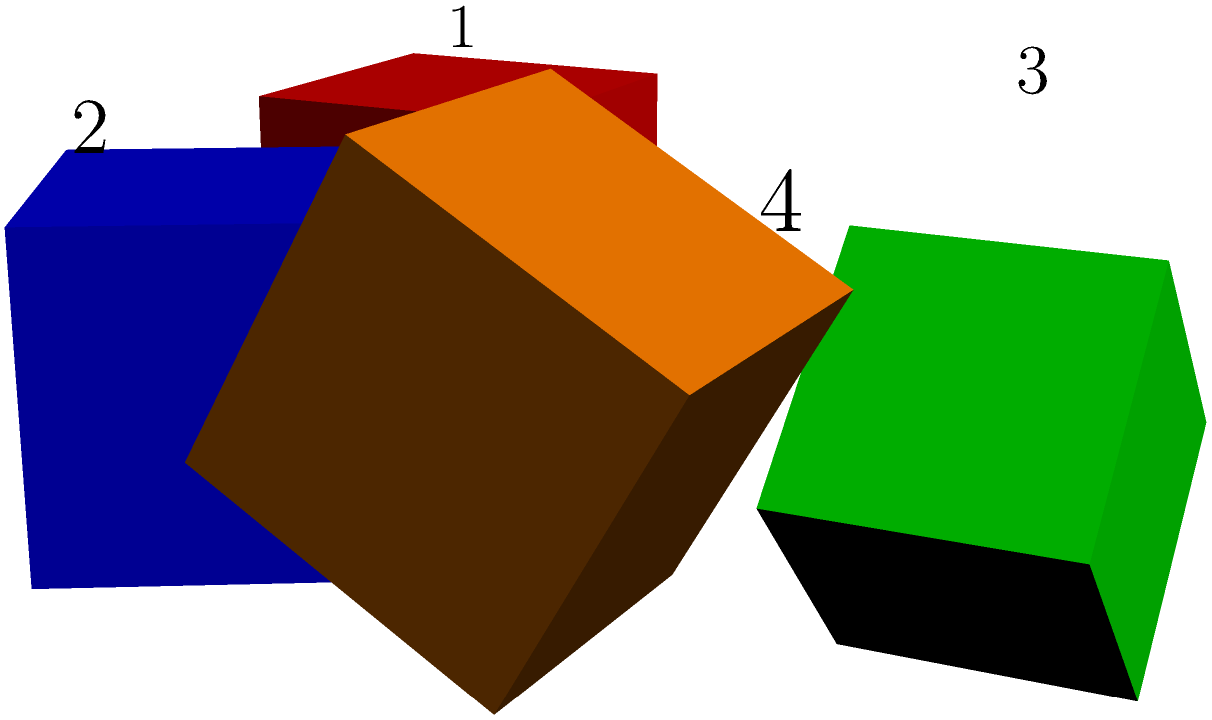As a marketing manager, you're tasked with selecting the most visually appealing package design for a new product line. Four prototypes are presented, each rotated differently on the store shelf. Which package design (numbered 1-4) would likely catch the most attention and stand out to customers? To determine the most visually appealing package design, we need to consider several factors:

1. Visibility of faces: The more faces visible, the more surface area for branding and information.
2. Unique orientation: An unusual angle can draw attention.
3. Dynamic appearance: Rotation that creates a sense of movement or energy.
4. Balance: A design that's stable yet interesting.

Analyzing each package:

1. Package 1 (red): Standard orientation, showing only two faces. Least dynamic.
2. Package 2 (blue): Rotated 30° around Z-axis, showing three faces. More interesting than 1.
3. Package 3 (green): Rotated 45° around Y-axis, showing three faces with a dynamic diagonal line.
4. Package 4 (orange): Rotated 60° around X-axis, showing three faces with the most dramatic angle.

Package 4 (orange) stands out the most because:
- It shows three faces, maximizing visible surface area.
- The 60° rotation is the most dramatic, creating a unique silhouette.
- The orientation suggests movement, drawing the eye.
- It maintains balance while being visually intriguing.

This design would likely catch the most attention on a store shelf, making it the optimal choice for a marketing manager aiming to make their product stand out.
Answer: Package 4 (orange) 